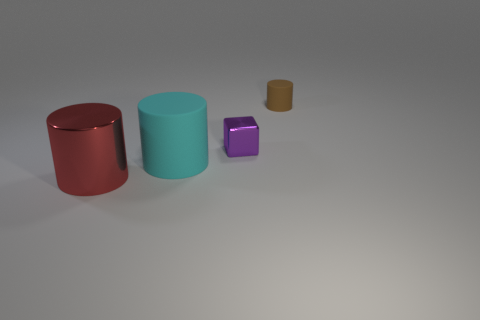There is a rubber object that is on the left side of the brown rubber cylinder; is it the same size as the large red shiny cylinder?
Ensure brevity in your answer.  Yes. How many other things are the same size as the brown cylinder?
Offer a terse response. 1. Are any tiny red blocks visible?
Keep it short and to the point. No. There is a metallic thing on the right side of the object that is to the left of the large cyan object; how big is it?
Your answer should be very brief. Small. There is a cylinder that is both in front of the tiny purple thing and right of the red thing; what is its color?
Ensure brevity in your answer.  Cyan. What number of other objects are there of the same shape as the small shiny thing?
Offer a very short reply. 0. What is the color of the metallic thing that is the same size as the brown rubber cylinder?
Make the answer very short. Purple. There is a big cylinder behind the big shiny thing; what color is it?
Provide a short and direct response. Cyan. Are there any cylinders that are right of the large red metal thing in front of the big matte thing?
Provide a succinct answer. Yes. Does the tiny purple thing have the same shape as the rubber object left of the small shiny block?
Give a very brief answer. No. 